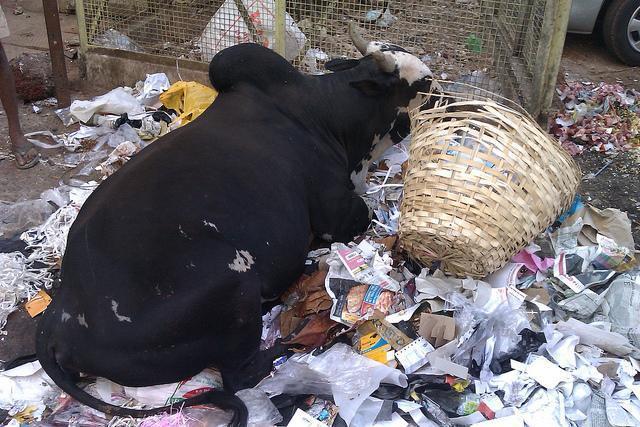How many motorcycles are on the road?
Give a very brief answer. 0. 